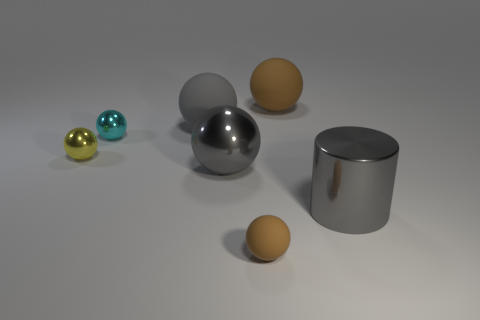Subtract all gray balls. How many balls are left? 4 Subtract all cyan metal spheres. How many spheres are left? 5 Subtract all yellow balls. Subtract all gray cylinders. How many balls are left? 5 Subtract all green cubes. How many red cylinders are left? 0 Add 4 tiny brown matte balls. How many tiny brown matte balls are left? 5 Add 3 cyan metal things. How many cyan metal things exist? 4 Add 2 tiny purple blocks. How many objects exist? 9 Subtract 0 blue cylinders. How many objects are left? 7 Subtract all balls. How many objects are left? 1 Subtract 6 spheres. How many spheres are left? 0 